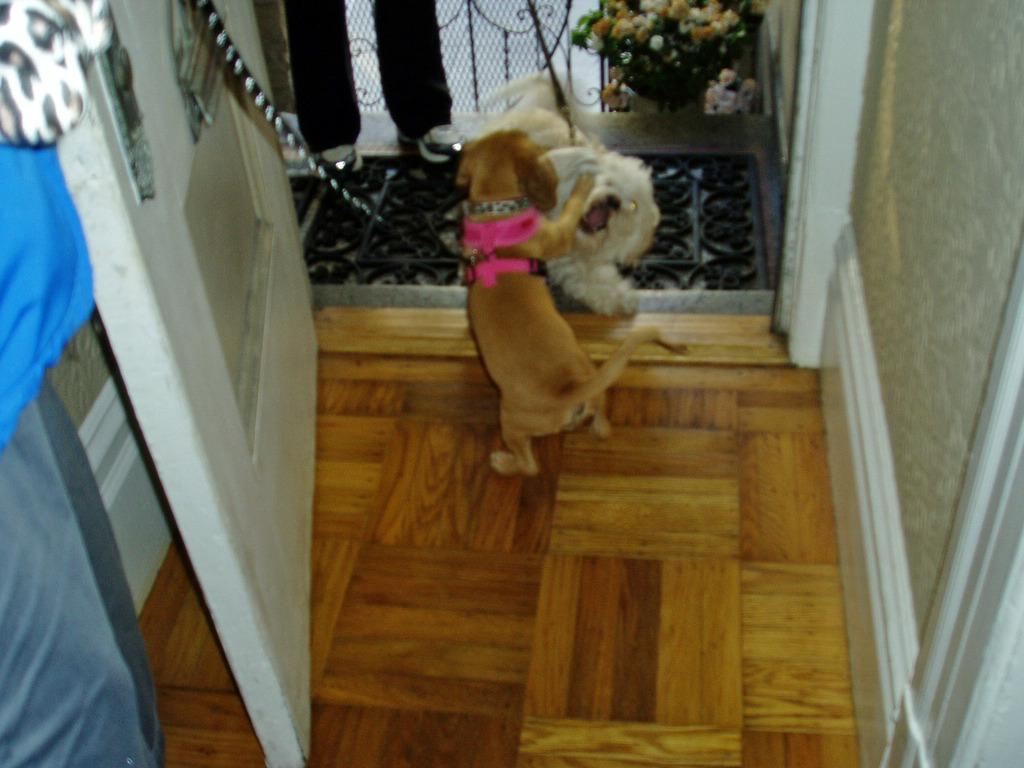What color is the floor in the image? The floor in the image is brown. What is the color of the door in the image? There is a white door in the image. What can be seen on the walls in the image? The walls are visible in the image. How many dogs are in the image, and what are their colors? There are two dogs in the image, one brown and one cream in color. Whose legs are visible in the image? Human legs are visible in the image. What type of decoration is present in the image? There are flowers in the image. How many letters are being passed around in the crowd in the image? There is no crowd or letters present in the image. What type of key is being used to open the door in the image? There is no key present in the image, as the door is already open. 